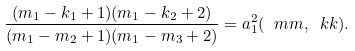Convert formula to latex. <formula><loc_0><loc_0><loc_500><loc_500>\frac { ( m _ { 1 } - k _ { 1 } + 1 ) ( m _ { 1 } - k _ { 2 } + 2 ) } { ( m _ { 1 } - m _ { 2 } + 1 ) ( m _ { 1 } - m _ { 3 } + 2 ) } = a _ { 1 } ^ { 2 } ( \ m m , \ k k ) .</formula> 